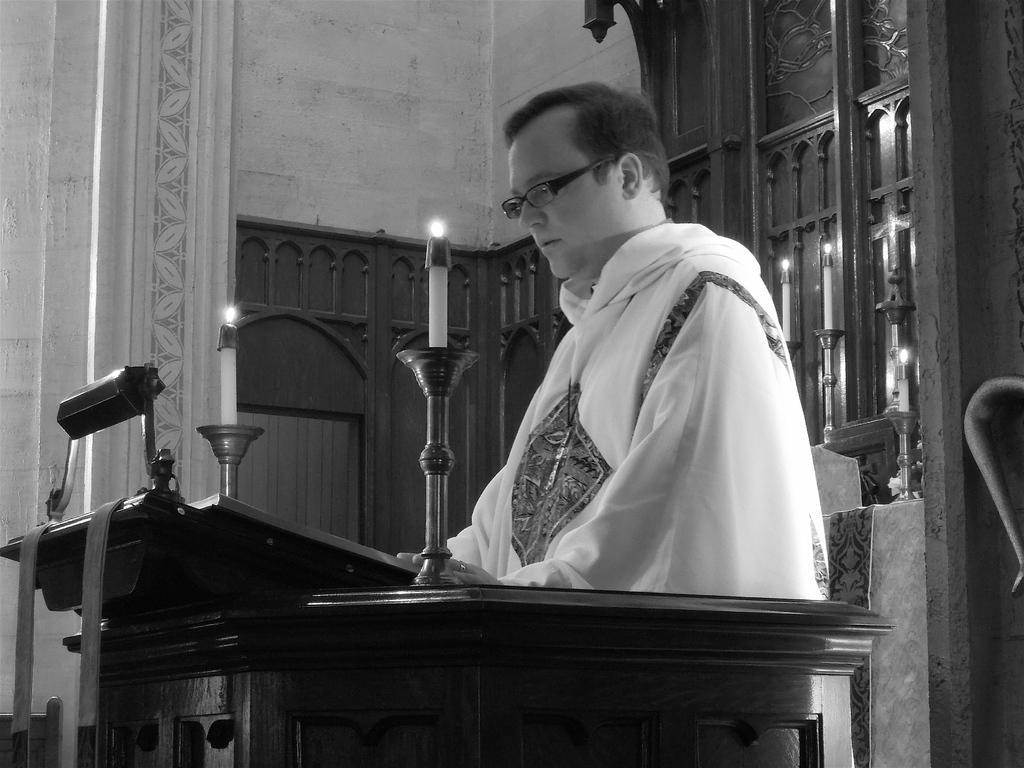In one or two sentences, can you explain what this image depicts? In this image there is a person standing near the podium , and there are two candles on the candle stands on the podium , and at the background there are candles on the candle stands, wall. 